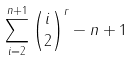Convert formula to latex. <formula><loc_0><loc_0><loc_500><loc_500>\sum _ { i = 2 } ^ { n + 1 } { i \choose 2 } ^ { r } - n + 1</formula> 